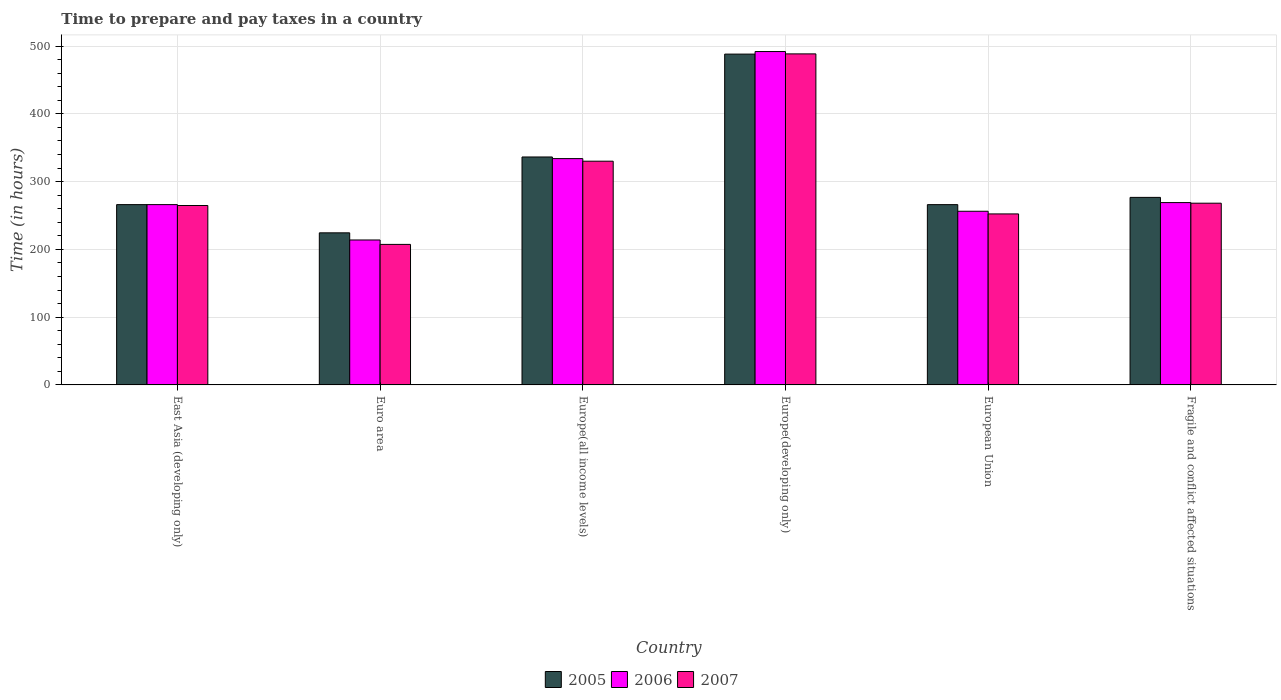How many groups of bars are there?
Offer a terse response. 6. Are the number of bars per tick equal to the number of legend labels?
Your response must be concise. Yes. Are the number of bars on each tick of the X-axis equal?
Your response must be concise. Yes. How many bars are there on the 1st tick from the left?
Your answer should be compact. 3. What is the label of the 3rd group of bars from the left?
Give a very brief answer. Europe(all income levels). In how many cases, is the number of bars for a given country not equal to the number of legend labels?
Your answer should be very brief. 0. What is the number of hours required to prepare and pay taxes in 2007 in Europe(developing only)?
Offer a terse response. 488.53. Across all countries, what is the maximum number of hours required to prepare and pay taxes in 2007?
Ensure brevity in your answer.  488.53. Across all countries, what is the minimum number of hours required to prepare and pay taxes in 2007?
Offer a terse response. 207.35. In which country was the number of hours required to prepare and pay taxes in 2006 maximum?
Ensure brevity in your answer.  Europe(developing only). What is the total number of hours required to prepare and pay taxes in 2005 in the graph?
Your response must be concise. 1857.9. What is the difference between the number of hours required to prepare and pay taxes in 2005 in European Union and that in Fragile and conflict affected situations?
Provide a short and direct response. -10.71. What is the difference between the number of hours required to prepare and pay taxes in 2005 in Europe(developing only) and the number of hours required to prepare and pay taxes in 2007 in European Union?
Your response must be concise. 235.86. What is the average number of hours required to prepare and pay taxes in 2006 per country?
Offer a terse response. 305.21. What is the difference between the number of hours required to prepare and pay taxes of/in 2005 and number of hours required to prepare and pay taxes of/in 2007 in Fragile and conflict affected situations?
Ensure brevity in your answer.  8.58. In how many countries, is the number of hours required to prepare and pay taxes in 2006 greater than 200 hours?
Give a very brief answer. 6. What is the ratio of the number of hours required to prepare and pay taxes in 2007 in Europe(all income levels) to that in European Union?
Ensure brevity in your answer.  1.31. Is the number of hours required to prepare and pay taxes in 2005 in Euro area less than that in Fragile and conflict affected situations?
Make the answer very short. Yes. What is the difference between the highest and the second highest number of hours required to prepare and pay taxes in 2006?
Offer a terse response. -222.9. What is the difference between the highest and the lowest number of hours required to prepare and pay taxes in 2007?
Give a very brief answer. 281.17. Is the sum of the number of hours required to prepare and pay taxes in 2007 in Europe(developing only) and Fragile and conflict affected situations greater than the maximum number of hours required to prepare and pay taxes in 2005 across all countries?
Your response must be concise. Yes. What does the 2nd bar from the right in East Asia (developing only) represents?
Give a very brief answer. 2006. Is it the case that in every country, the sum of the number of hours required to prepare and pay taxes in 2007 and number of hours required to prepare and pay taxes in 2005 is greater than the number of hours required to prepare and pay taxes in 2006?
Provide a succinct answer. Yes. Are all the bars in the graph horizontal?
Provide a short and direct response. No. How many countries are there in the graph?
Your answer should be very brief. 6. Does the graph contain grids?
Keep it short and to the point. Yes. What is the title of the graph?
Your response must be concise. Time to prepare and pay taxes in a country. What is the label or title of the X-axis?
Your response must be concise. Country. What is the label or title of the Y-axis?
Your answer should be compact. Time (in hours). What is the Time (in hours) in 2005 in East Asia (developing only)?
Give a very brief answer. 266.08. What is the Time (in hours) of 2006 in East Asia (developing only)?
Offer a very short reply. 266.08. What is the Time (in hours) of 2007 in East Asia (developing only)?
Make the answer very short. 264.75. What is the Time (in hours) of 2005 in Euro area?
Provide a short and direct response. 224.44. What is the Time (in hours) in 2006 in Euro area?
Provide a succinct answer. 213.88. What is the Time (in hours) of 2007 in Euro area?
Your response must be concise. 207.35. What is the Time (in hours) in 2005 in Europe(all income levels)?
Your response must be concise. 336.38. What is the Time (in hours) in 2006 in Europe(all income levels)?
Your answer should be very brief. 333.99. What is the Time (in hours) in 2007 in Europe(all income levels)?
Provide a short and direct response. 330.14. What is the Time (in hours) of 2005 in Europe(developing only)?
Ensure brevity in your answer.  488.21. What is the Time (in hours) of 2006 in Europe(developing only)?
Your response must be concise. 491.97. What is the Time (in hours) of 2007 in Europe(developing only)?
Your answer should be compact. 488.53. What is the Time (in hours) of 2005 in European Union?
Your response must be concise. 266.04. What is the Time (in hours) in 2006 in European Union?
Your answer should be compact. 256.27. What is the Time (in hours) in 2007 in European Union?
Give a very brief answer. 252.35. What is the Time (in hours) of 2005 in Fragile and conflict affected situations?
Keep it short and to the point. 276.75. What is the Time (in hours) in 2006 in Fragile and conflict affected situations?
Keep it short and to the point. 269.07. What is the Time (in hours) of 2007 in Fragile and conflict affected situations?
Provide a short and direct response. 268.17. Across all countries, what is the maximum Time (in hours) of 2005?
Give a very brief answer. 488.21. Across all countries, what is the maximum Time (in hours) of 2006?
Give a very brief answer. 491.97. Across all countries, what is the maximum Time (in hours) of 2007?
Provide a short and direct response. 488.53. Across all countries, what is the minimum Time (in hours) of 2005?
Your response must be concise. 224.44. Across all countries, what is the minimum Time (in hours) in 2006?
Give a very brief answer. 213.88. Across all countries, what is the minimum Time (in hours) in 2007?
Your answer should be very brief. 207.35. What is the total Time (in hours) in 2005 in the graph?
Provide a short and direct response. 1857.9. What is the total Time (in hours) in 2006 in the graph?
Provide a succinct answer. 1831.27. What is the total Time (in hours) in 2007 in the graph?
Provide a succinct answer. 1811.29. What is the difference between the Time (in hours) of 2005 in East Asia (developing only) and that in Euro area?
Keep it short and to the point. 41.65. What is the difference between the Time (in hours) in 2006 in East Asia (developing only) and that in Euro area?
Ensure brevity in your answer.  52.2. What is the difference between the Time (in hours) in 2007 in East Asia (developing only) and that in Euro area?
Give a very brief answer. 57.4. What is the difference between the Time (in hours) of 2005 in East Asia (developing only) and that in Europe(all income levels)?
Ensure brevity in your answer.  -70.3. What is the difference between the Time (in hours) in 2006 in East Asia (developing only) and that in Europe(all income levels)?
Provide a succinct answer. -67.91. What is the difference between the Time (in hours) of 2007 in East Asia (developing only) and that in Europe(all income levels)?
Keep it short and to the point. -65.39. What is the difference between the Time (in hours) of 2005 in East Asia (developing only) and that in Europe(developing only)?
Your answer should be very brief. -222.12. What is the difference between the Time (in hours) in 2006 in East Asia (developing only) and that in Europe(developing only)?
Your answer should be very brief. -225.89. What is the difference between the Time (in hours) of 2007 in East Asia (developing only) and that in Europe(developing only)?
Give a very brief answer. -223.78. What is the difference between the Time (in hours) in 2005 in East Asia (developing only) and that in European Union?
Provide a short and direct response. 0.04. What is the difference between the Time (in hours) of 2006 in East Asia (developing only) and that in European Union?
Keep it short and to the point. 9.81. What is the difference between the Time (in hours) in 2007 in East Asia (developing only) and that in European Union?
Offer a terse response. 12.4. What is the difference between the Time (in hours) in 2005 in East Asia (developing only) and that in Fragile and conflict affected situations?
Keep it short and to the point. -10.67. What is the difference between the Time (in hours) of 2006 in East Asia (developing only) and that in Fragile and conflict affected situations?
Ensure brevity in your answer.  -2.99. What is the difference between the Time (in hours) in 2007 in East Asia (developing only) and that in Fragile and conflict affected situations?
Make the answer very short. -3.42. What is the difference between the Time (in hours) of 2005 in Euro area and that in Europe(all income levels)?
Offer a very short reply. -111.95. What is the difference between the Time (in hours) in 2006 in Euro area and that in Europe(all income levels)?
Make the answer very short. -120.11. What is the difference between the Time (in hours) in 2007 in Euro area and that in Europe(all income levels)?
Give a very brief answer. -122.79. What is the difference between the Time (in hours) of 2005 in Euro area and that in Europe(developing only)?
Your response must be concise. -263.77. What is the difference between the Time (in hours) of 2006 in Euro area and that in Europe(developing only)?
Ensure brevity in your answer.  -278.09. What is the difference between the Time (in hours) in 2007 in Euro area and that in Europe(developing only)?
Make the answer very short. -281.17. What is the difference between the Time (in hours) of 2005 in Euro area and that in European Union?
Ensure brevity in your answer.  -41.6. What is the difference between the Time (in hours) of 2006 in Euro area and that in European Union?
Your response must be concise. -42.39. What is the difference between the Time (in hours) in 2007 in Euro area and that in European Union?
Provide a succinct answer. -44.99. What is the difference between the Time (in hours) of 2005 in Euro area and that in Fragile and conflict affected situations?
Your answer should be compact. -52.31. What is the difference between the Time (in hours) of 2006 in Euro area and that in Fragile and conflict affected situations?
Keep it short and to the point. -55.19. What is the difference between the Time (in hours) in 2007 in Euro area and that in Fragile and conflict affected situations?
Give a very brief answer. -60.82. What is the difference between the Time (in hours) in 2005 in Europe(all income levels) and that in Europe(developing only)?
Your answer should be very brief. -151.82. What is the difference between the Time (in hours) in 2006 in Europe(all income levels) and that in Europe(developing only)?
Ensure brevity in your answer.  -157.98. What is the difference between the Time (in hours) of 2007 in Europe(all income levels) and that in Europe(developing only)?
Offer a terse response. -158.38. What is the difference between the Time (in hours) in 2005 in Europe(all income levels) and that in European Union?
Make the answer very short. 70.34. What is the difference between the Time (in hours) in 2006 in Europe(all income levels) and that in European Union?
Your answer should be compact. 77.72. What is the difference between the Time (in hours) in 2007 in Europe(all income levels) and that in European Union?
Provide a short and direct response. 77.8. What is the difference between the Time (in hours) in 2005 in Europe(all income levels) and that in Fragile and conflict affected situations?
Ensure brevity in your answer.  59.63. What is the difference between the Time (in hours) in 2006 in Europe(all income levels) and that in Fragile and conflict affected situations?
Give a very brief answer. 64.92. What is the difference between the Time (in hours) in 2007 in Europe(all income levels) and that in Fragile and conflict affected situations?
Your response must be concise. 61.97. What is the difference between the Time (in hours) of 2005 in Europe(developing only) and that in European Union?
Provide a short and direct response. 222.17. What is the difference between the Time (in hours) in 2006 in Europe(developing only) and that in European Union?
Offer a terse response. 235.7. What is the difference between the Time (in hours) in 2007 in Europe(developing only) and that in European Union?
Offer a terse response. 236.18. What is the difference between the Time (in hours) of 2005 in Europe(developing only) and that in Fragile and conflict affected situations?
Provide a short and direct response. 211.46. What is the difference between the Time (in hours) in 2006 in Europe(developing only) and that in Fragile and conflict affected situations?
Provide a succinct answer. 222.9. What is the difference between the Time (in hours) in 2007 in Europe(developing only) and that in Fragile and conflict affected situations?
Make the answer very short. 220.36. What is the difference between the Time (in hours) of 2005 in European Union and that in Fragile and conflict affected situations?
Give a very brief answer. -10.71. What is the difference between the Time (in hours) of 2006 in European Union and that in Fragile and conflict affected situations?
Ensure brevity in your answer.  -12.8. What is the difference between the Time (in hours) of 2007 in European Union and that in Fragile and conflict affected situations?
Provide a succinct answer. -15.83. What is the difference between the Time (in hours) of 2005 in East Asia (developing only) and the Time (in hours) of 2006 in Euro area?
Make the answer very short. 52.2. What is the difference between the Time (in hours) in 2005 in East Asia (developing only) and the Time (in hours) in 2007 in Euro area?
Offer a terse response. 58.73. What is the difference between the Time (in hours) in 2006 in East Asia (developing only) and the Time (in hours) in 2007 in Euro area?
Your response must be concise. 58.73. What is the difference between the Time (in hours) in 2005 in East Asia (developing only) and the Time (in hours) in 2006 in Europe(all income levels)?
Make the answer very short. -67.91. What is the difference between the Time (in hours) in 2005 in East Asia (developing only) and the Time (in hours) in 2007 in Europe(all income levels)?
Your answer should be very brief. -64.06. What is the difference between the Time (in hours) in 2006 in East Asia (developing only) and the Time (in hours) in 2007 in Europe(all income levels)?
Provide a short and direct response. -64.06. What is the difference between the Time (in hours) of 2005 in East Asia (developing only) and the Time (in hours) of 2006 in Europe(developing only)?
Give a very brief answer. -225.89. What is the difference between the Time (in hours) in 2005 in East Asia (developing only) and the Time (in hours) in 2007 in Europe(developing only)?
Your response must be concise. -222.44. What is the difference between the Time (in hours) of 2006 in East Asia (developing only) and the Time (in hours) of 2007 in Europe(developing only)?
Your response must be concise. -222.44. What is the difference between the Time (in hours) in 2005 in East Asia (developing only) and the Time (in hours) in 2006 in European Union?
Your answer should be very brief. 9.81. What is the difference between the Time (in hours) in 2005 in East Asia (developing only) and the Time (in hours) in 2007 in European Union?
Offer a terse response. 13.74. What is the difference between the Time (in hours) in 2006 in East Asia (developing only) and the Time (in hours) in 2007 in European Union?
Your response must be concise. 13.74. What is the difference between the Time (in hours) in 2005 in East Asia (developing only) and the Time (in hours) in 2006 in Fragile and conflict affected situations?
Your response must be concise. -2.99. What is the difference between the Time (in hours) of 2005 in East Asia (developing only) and the Time (in hours) of 2007 in Fragile and conflict affected situations?
Offer a very short reply. -2.09. What is the difference between the Time (in hours) in 2006 in East Asia (developing only) and the Time (in hours) in 2007 in Fragile and conflict affected situations?
Your answer should be compact. -2.09. What is the difference between the Time (in hours) in 2005 in Euro area and the Time (in hours) in 2006 in Europe(all income levels)?
Provide a short and direct response. -109.55. What is the difference between the Time (in hours) in 2005 in Euro area and the Time (in hours) in 2007 in Europe(all income levels)?
Make the answer very short. -105.71. What is the difference between the Time (in hours) in 2006 in Euro area and the Time (in hours) in 2007 in Europe(all income levels)?
Your answer should be very brief. -116.26. What is the difference between the Time (in hours) in 2005 in Euro area and the Time (in hours) in 2006 in Europe(developing only)?
Provide a succinct answer. -267.53. What is the difference between the Time (in hours) in 2005 in Euro area and the Time (in hours) in 2007 in Europe(developing only)?
Offer a very short reply. -264.09. What is the difference between the Time (in hours) of 2006 in Euro area and the Time (in hours) of 2007 in Europe(developing only)?
Give a very brief answer. -274.65. What is the difference between the Time (in hours) in 2005 in Euro area and the Time (in hours) in 2006 in European Union?
Your response must be concise. -31.83. What is the difference between the Time (in hours) of 2005 in Euro area and the Time (in hours) of 2007 in European Union?
Your answer should be compact. -27.91. What is the difference between the Time (in hours) in 2006 in Euro area and the Time (in hours) in 2007 in European Union?
Give a very brief answer. -38.46. What is the difference between the Time (in hours) of 2005 in Euro area and the Time (in hours) of 2006 in Fragile and conflict affected situations?
Give a very brief answer. -44.63. What is the difference between the Time (in hours) in 2005 in Euro area and the Time (in hours) in 2007 in Fragile and conflict affected situations?
Make the answer very short. -43.73. What is the difference between the Time (in hours) in 2006 in Euro area and the Time (in hours) in 2007 in Fragile and conflict affected situations?
Offer a very short reply. -54.29. What is the difference between the Time (in hours) of 2005 in Europe(all income levels) and the Time (in hours) of 2006 in Europe(developing only)?
Provide a succinct answer. -155.59. What is the difference between the Time (in hours) in 2005 in Europe(all income levels) and the Time (in hours) in 2007 in Europe(developing only)?
Provide a short and direct response. -152.14. What is the difference between the Time (in hours) of 2006 in Europe(all income levels) and the Time (in hours) of 2007 in Europe(developing only)?
Keep it short and to the point. -154.54. What is the difference between the Time (in hours) in 2005 in Europe(all income levels) and the Time (in hours) in 2006 in European Union?
Keep it short and to the point. 80.11. What is the difference between the Time (in hours) of 2005 in Europe(all income levels) and the Time (in hours) of 2007 in European Union?
Ensure brevity in your answer.  84.04. What is the difference between the Time (in hours) of 2006 in Europe(all income levels) and the Time (in hours) of 2007 in European Union?
Ensure brevity in your answer.  81.64. What is the difference between the Time (in hours) in 2005 in Europe(all income levels) and the Time (in hours) in 2006 in Fragile and conflict affected situations?
Your response must be concise. 67.31. What is the difference between the Time (in hours) in 2005 in Europe(all income levels) and the Time (in hours) in 2007 in Fragile and conflict affected situations?
Provide a succinct answer. 68.21. What is the difference between the Time (in hours) of 2006 in Europe(all income levels) and the Time (in hours) of 2007 in Fragile and conflict affected situations?
Keep it short and to the point. 65.82. What is the difference between the Time (in hours) in 2005 in Europe(developing only) and the Time (in hours) in 2006 in European Union?
Give a very brief answer. 231.94. What is the difference between the Time (in hours) of 2005 in Europe(developing only) and the Time (in hours) of 2007 in European Union?
Provide a short and direct response. 235.86. What is the difference between the Time (in hours) in 2006 in Europe(developing only) and the Time (in hours) in 2007 in European Union?
Ensure brevity in your answer.  239.63. What is the difference between the Time (in hours) of 2005 in Europe(developing only) and the Time (in hours) of 2006 in Fragile and conflict affected situations?
Provide a succinct answer. 219.14. What is the difference between the Time (in hours) of 2005 in Europe(developing only) and the Time (in hours) of 2007 in Fragile and conflict affected situations?
Your response must be concise. 220.03. What is the difference between the Time (in hours) in 2006 in Europe(developing only) and the Time (in hours) in 2007 in Fragile and conflict affected situations?
Keep it short and to the point. 223.8. What is the difference between the Time (in hours) in 2005 in European Union and the Time (in hours) in 2006 in Fragile and conflict affected situations?
Keep it short and to the point. -3.03. What is the difference between the Time (in hours) in 2005 in European Union and the Time (in hours) in 2007 in Fragile and conflict affected situations?
Ensure brevity in your answer.  -2.13. What is the difference between the Time (in hours) in 2006 in European Union and the Time (in hours) in 2007 in Fragile and conflict affected situations?
Provide a succinct answer. -11.9. What is the average Time (in hours) of 2005 per country?
Offer a very short reply. 309.65. What is the average Time (in hours) of 2006 per country?
Provide a succinct answer. 305.21. What is the average Time (in hours) in 2007 per country?
Make the answer very short. 301.88. What is the difference between the Time (in hours) of 2005 and Time (in hours) of 2007 in East Asia (developing only)?
Provide a short and direct response. 1.33. What is the difference between the Time (in hours) of 2006 and Time (in hours) of 2007 in East Asia (developing only)?
Provide a short and direct response. 1.33. What is the difference between the Time (in hours) in 2005 and Time (in hours) in 2006 in Euro area?
Make the answer very short. 10.56. What is the difference between the Time (in hours) of 2005 and Time (in hours) of 2007 in Euro area?
Provide a short and direct response. 17.08. What is the difference between the Time (in hours) of 2006 and Time (in hours) of 2007 in Euro area?
Provide a short and direct response. 6.53. What is the difference between the Time (in hours) of 2005 and Time (in hours) of 2006 in Europe(all income levels)?
Provide a short and direct response. 2.39. What is the difference between the Time (in hours) in 2005 and Time (in hours) in 2007 in Europe(all income levels)?
Your answer should be compact. 6.24. What is the difference between the Time (in hours) in 2006 and Time (in hours) in 2007 in Europe(all income levels)?
Your response must be concise. 3.84. What is the difference between the Time (in hours) of 2005 and Time (in hours) of 2006 in Europe(developing only)?
Your response must be concise. -3.77. What is the difference between the Time (in hours) in 2005 and Time (in hours) in 2007 in Europe(developing only)?
Keep it short and to the point. -0.32. What is the difference between the Time (in hours) in 2006 and Time (in hours) in 2007 in Europe(developing only)?
Provide a succinct answer. 3.44. What is the difference between the Time (in hours) of 2005 and Time (in hours) of 2006 in European Union?
Ensure brevity in your answer.  9.77. What is the difference between the Time (in hours) of 2005 and Time (in hours) of 2007 in European Union?
Your answer should be very brief. 13.69. What is the difference between the Time (in hours) in 2006 and Time (in hours) in 2007 in European Union?
Your answer should be very brief. 3.92. What is the difference between the Time (in hours) in 2005 and Time (in hours) in 2006 in Fragile and conflict affected situations?
Ensure brevity in your answer.  7.68. What is the difference between the Time (in hours) of 2005 and Time (in hours) of 2007 in Fragile and conflict affected situations?
Your response must be concise. 8.58. What is the difference between the Time (in hours) of 2006 and Time (in hours) of 2007 in Fragile and conflict affected situations?
Keep it short and to the point. 0.9. What is the ratio of the Time (in hours) of 2005 in East Asia (developing only) to that in Euro area?
Make the answer very short. 1.19. What is the ratio of the Time (in hours) of 2006 in East Asia (developing only) to that in Euro area?
Provide a short and direct response. 1.24. What is the ratio of the Time (in hours) of 2007 in East Asia (developing only) to that in Euro area?
Keep it short and to the point. 1.28. What is the ratio of the Time (in hours) of 2005 in East Asia (developing only) to that in Europe(all income levels)?
Ensure brevity in your answer.  0.79. What is the ratio of the Time (in hours) in 2006 in East Asia (developing only) to that in Europe(all income levels)?
Keep it short and to the point. 0.8. What is the ratio of the Time (in hours) in 2007 in East Asia (developing only) to that in Europe(all income levels)?
Give a very brief answer. 0.8. What is the ratio of the Time (in hours) of 2005 in East Asia (developing only) to that in Europe(developing only)?
Ensure brevity in your answer.  0.55. What is the ratio of the Time (in hours) of 2006 in East Asia (developing only) to that in Europe(developing only)?
Offer a very short reply. 0.54. What is the ratio of the Time (in hours) in 2007 in East Asia (developing only) to that in Europe(developing only)?
Keep it short and to the point. 0.54. What is the ratio of the Time (in hours) of 2006 in East Asia (developing only) to that in European Union?
Make the answer very short. 1.04. What is the ratio of the Time (in hours) of 2007 in East Asia (developing only) to that in European Union?
Your answer should be very brief. 1.05. What is the ratio of the Time (in hours) in 2005 in East Asia (developing only) to that in Fragile and conflict affected situations?
Give a very brief answer. 0.96. What is the ratio of the Time (in hours) of 2006 in East Asia (developing only) to that in Fragile and conflict affected situations?
Your response must be concise. 0.99. What is the ratio of the Time (in hours) of 2007 in East Asia (developing only) to that in Fragile and conflict affected situations?
Give a very brief answer. 0.99. What is the ratio of the Time (in hours) in 2005 in Euro area to that in Europe(all income levels)?
Your answer should be very brief. 0.67. What is the ratio of the Time (in hours) of 2006 in Euro area to that in Europe(all income levels)?
Ensure brevity in your answer.  0.64. What is the ratio of the Time (in hours) of 2007 in Euro area to that in Europe(all income levels)?
Give a very brief answer. 0.63. What is the ratio of the Time (in hours) of 2005 in Euro area to that in Europe(developing only)?
Provide a short and direct response. 0.46. What is the ratio of the Time (in hours) of 2006 in Euro area to that in Europe(developing only)?
Keep it short and to the point. 0.43. What is the ratio of the Time (in hours) in 2007 in Euro area to that in Europe(developing only)?
Offer a very short reply. 0.42. What is the ratio of the Time (in hours) of 2005 in Euro area to that in European Union?
Make the answer very short. 0.84. What is the ratio of the Time (in hours) of 2006 in Euro area to that in European Union?
Make the answer very short. 0.83. What is the ratio of the Time (in hours) of 2007 in Euro area to that in European Union?
Keep it short and to the point. 0.82. What is the ratio of the Time (in hours) of 2005 in Euro area to that in Fragile and conflict affected situations?
Offer a terse response. 0.81. What is the ratio of the Time (in hours) in 2006 in Euro area to that in Fragile and conflict affected situations?
Your answer should be compact. 0.79. What is the ratio of the Time (in hours) in 2007 in Euro area to that in Fragile and conflict affected situations?
Your answer should be compact. 0.77. What is the ratio of the Time (in hours) of 2005 in Europe(all income levels) to that in Europe(developing only)?
Provide a short and direct response. 0.69. What is the ratio of the Time (in hours) in 2006 in Europe(all income levels) to that in Europe(developing only)?
Give a very brief answer. 0.68. What is the ratio of the Time (in hours) of 2007 in Europe(all income levels) to that in Europe(developing only)?
Offer a terse response. 0.68. What is the ratio of the Time (in hours) in 2005 in Europe(all income levels) to that in European Union?
Your response must be concise. 1.26. What is the ratio of the Time (in hours) in 2006 in Europe(all income levels) to that in European Union?
Offer a very short reply. 1.3. What is the ratio of the Time (in hours) in 2007 in Europe(all income levels) to that in European Union?
Ensure brevity in your answer.  1.31. What is the ratio of the Time (in hours) in 2005 in Europe(all income levels) to that in Fragile and conflict affected situations?
Your answer should be compact. 1.22. What is the ratio of the Time (in hours) of 2006 in Europe(all income levels) to that in Fragile and conflict affected situations?
Keep it short and to the point. 1.24. What is the ratio of the Time (in hours) of 2007 in Europe(all income levels) to that in Fragile and conflict affected situations?
Offer a very short reply. 1.23. What is the ratio of the Time (in hours) in 2005 in Europe(developing only) to that in European Union?
Your answer should be very brief. 1.84. What is the ratio of the Time (in hours) of 2006 in Europe(developing only) to that in European Union?
Your answer should be very brief. 1.92. What is the ratio of the Time (in hours) in 2007 in Europe(developing only) to that in European Union?
Offer a very short reply. 1.94. What is the ratio of the Time (in hours) of 2005 in Europe(developing only) to that in Fragile and conflict affected situations?
Provide a succinct answer. 1.76. What is the ratio of the Time (in hours) in 2006 in Europe(developing only) to that in Fragile and conflict affected situations?
Your answer should be very brief. 1.83. What is the ratio of the Time (in hours) of 2007 in Europe(developing only) to that in Fragile and conflict affected situations?
Make the answer very short. 1.82. What is the ratio of the Time (in hours) in 2005 in European Union to that in Fragile and conflict affected situations?
Your answer should be compact. 0.96. What is the ratio of the Time (in hours) of 2006 in European Union to that in Fragile and conflict affected situations?
Your answer should be very brief. 0.95. What is the ratio of the Time (in hours) in 2007 in European Union to that in Fragile and conflict affected situations?
Provide a short and direct response. 0.94. What is the difference between the highest and the second highest Time (in hours) in 2005?
Make the answer very short. 151.82. What is the difference between the highest and the second highest Time (in hours) of 2006?
Ensure brevity in your answer.  157.98. What is the difference between the highest and the second highest Time (in hours) of 2007?
Offer a terse response. 158.38. What is the difference between the highest and the lowest Time (in hours) of 2005?
Your answer should be very brief. 263.77. What is the difference between the highest and the lowest Time (in hours) in 2006?
Give a very brief answer. 278.09. What is the difference between the highest and the lowest Time (in hours) of 2007?
Your answer should be very brief. 281.17. 